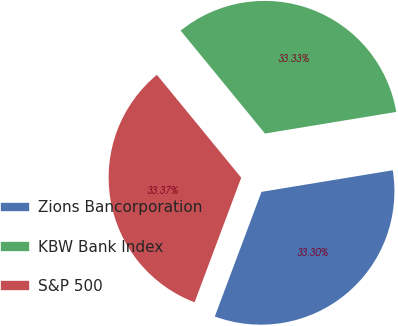Convert chart. <chart><loc_0><loc_0><loc_500><loc_500><pie_chart><fcel>Zions Bancorporation<fcel>KBW Bank Index<fcel>S&P 500<nl><fcel>33.3%<fcel>33.33%<fcel>33.37%<nl></chart> 